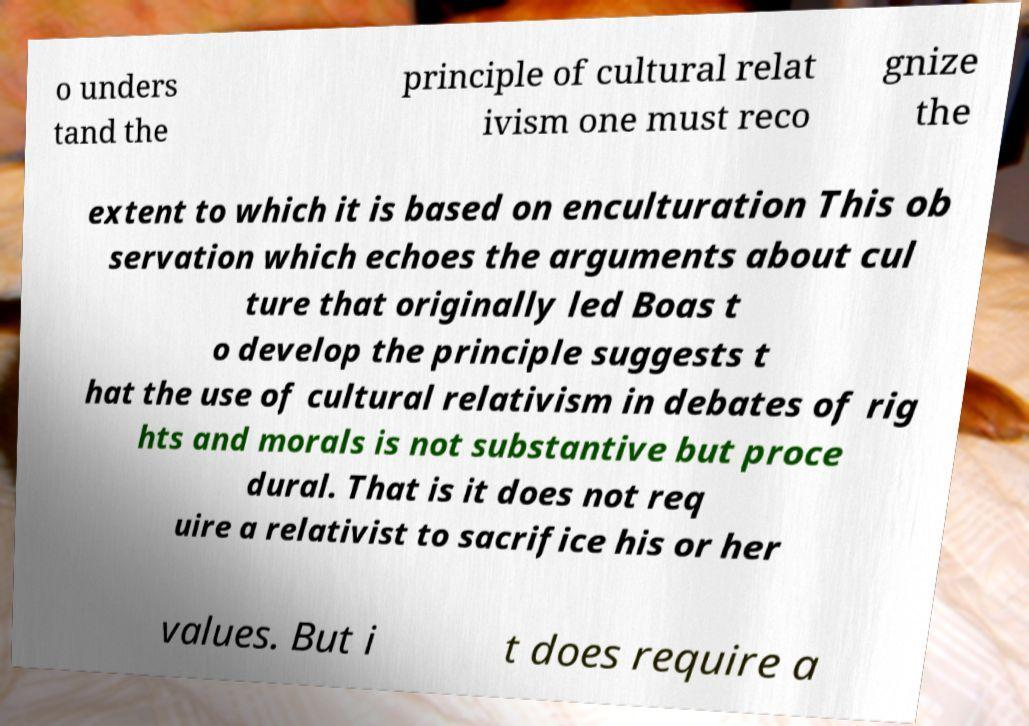Please identify and transcribe the text found in this image. o unders tand the principle of cultural relat ivism one must reco gnize the extent to which it is based on enculturation This ob servation which echoes the arguments about cul ture that originally led Boas t o develop the principle suggests t hat the use of cultural relativism in debates of rig hts and morals is not substantive but proce dural. That is it does not req uire a relativist to sacrifice his or her values. But i t does require a 